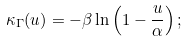Convert formula to latex. <formula><loc_0><loc_0><loc_500><loc_500>\kappa _ { \Gamma } ( u ) = - \beta \ln \left ( 1 - \frac { u } { \alpha } \right ) ;</formula> 